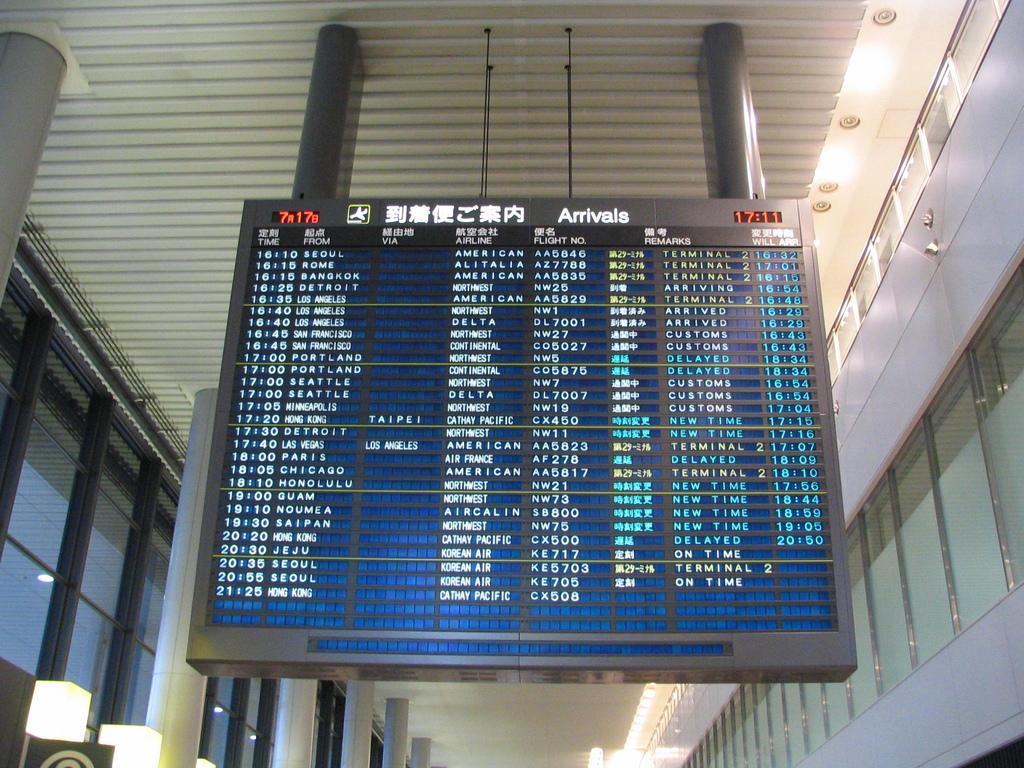In one or two sentences, can you explain what this image depicts? This image consists of a board. It looks like an airport. In this board there are timings of the flights. At the top, there is a roof. On the left, there are pillars. On the right, there are windows. 